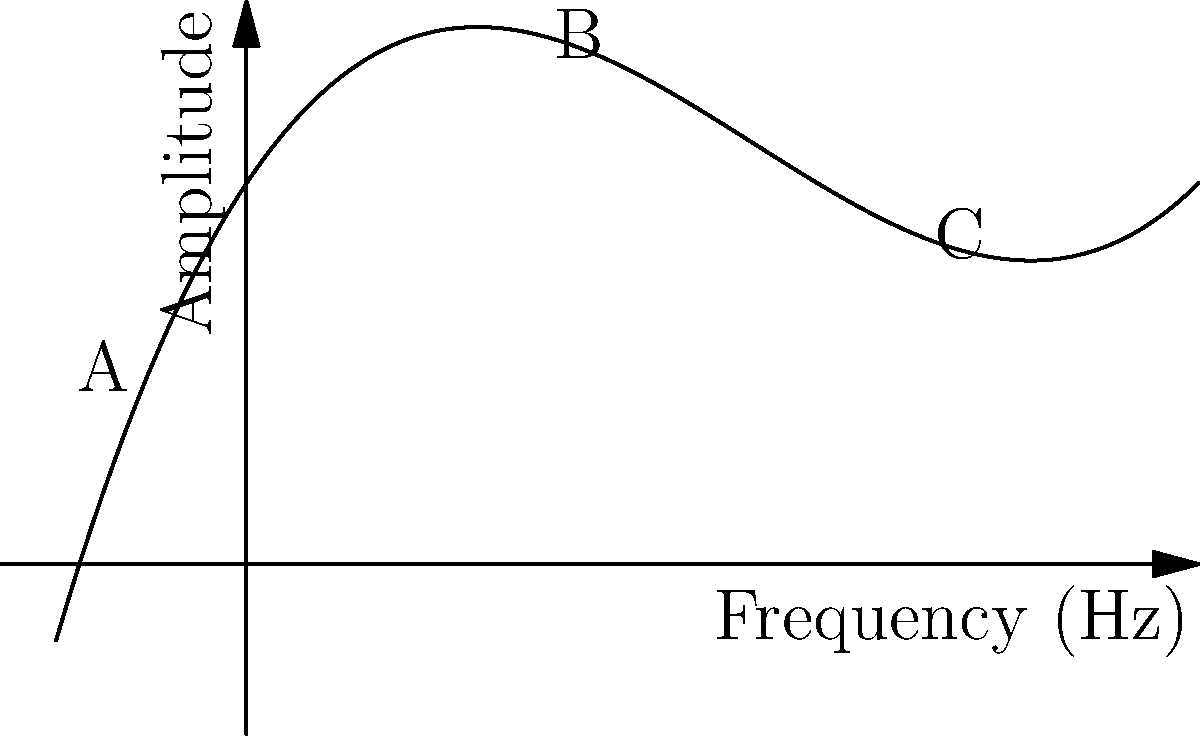The graph represents the amplitude response curve of a bass distortion pedal across different frequencies. If this polynomial function is given by $f(x) = 0.1x^3 - 0.8x^2 + 1.5x + 2$, where $x$ represents frequency in kHz and $f(x)$ represents amplitude, at which labeled point does the pedal produce the most prominent mid-range boost? To determine the point with the most prominent mid-range boost, we need to analyze the behavior of the function at each labeled point:

1. Point A: Located at a low frequency (negative x-value). This represents the bass frequencies.

2. Point B: Located at approximately x = 1.5 kHz. This is in the mid-range frequencies.

3. Point C: Located at a higher frequency (x ≈ 3.5 kHz). This represents treble frequencies.

The mid-range boost would be represented by a local maximum in the middle of the curve. To find this, we can calculate the derivative of the function:

$f'(x) = 0.3x^2 - 1.6x + 1.5$

Setting $f'(x) = 0$ and solving:

$0.3x^2 - 1.6x + 1.5 = 0$

Using the quadratic formula, we get x ≈ 1.47 and x ≈ 3.42

The solution closer to the middle of our range is x ≈ 1.47, which corresponds closely to point B.

Therefore, point B represents the most prominent mid-range boost in the pedal's response curve.
Answer: B 